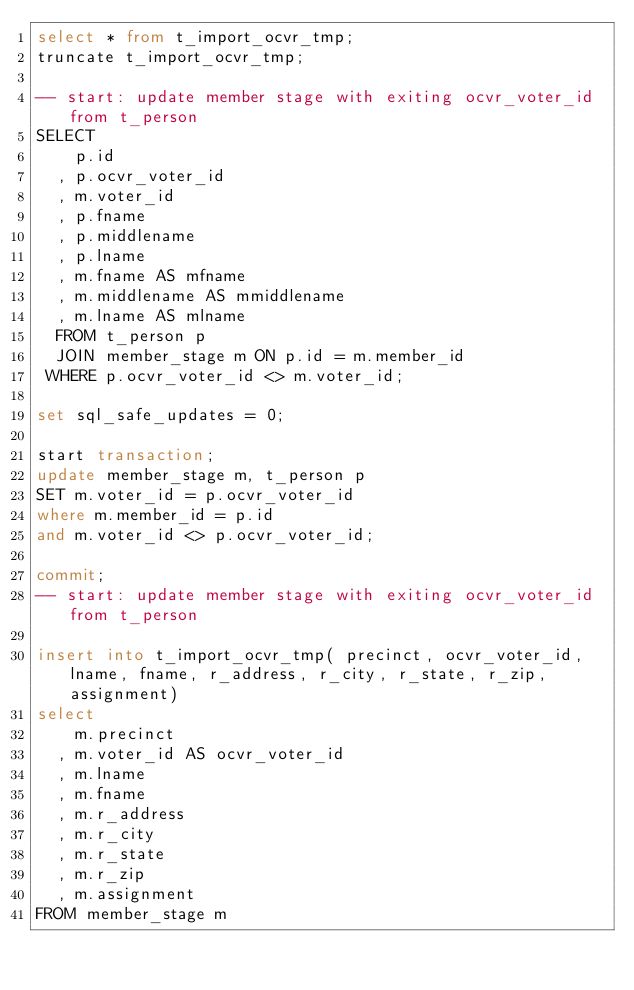Convert code to text. <code><loc_0><loc_0><loc_500><loc_500><_SQL_>select * from t_import_ocvr_tmp;
truncate t_import_ocvr_tmp;

-- start: update member stage with exiting ocvr_voter_id from t_person
SELECT
    p.id
  , p.ocvr_voter_id
  , m.voter_id
  , p.fname
  , p.middlename
  , p.lname
  , m.fname AS mfname
  , m.middlename AS mmiddlename
  , m.lname AS mlname
  FROM t_person p 
  JOIN member_stage m ON p.id = m.member_id
 WHERE p.ocvr_voter_id <> m.voter_id;

set sql_safe_updates = 0;

start transaction;
update member_stage m, t_person p
SET m.voter_id = p.ocvr_voter_id
where m.member_id = p.id
and m.voter_id <> p.ocvr_voter_id;

commit;
-- start: update member stage with exiting ocvr_voter_id from t_person

insert into t_import_ocvr_tmp( precinct, ocvr_voter_id, lname, fname, r_address, r_city, r_state, r_zip, assignment)
select 
    m.precinct
  , m.voter_id AS ocvr_voter_id
  , m.lname
  , m.fname
  , m.r_address
  , m.r_city
  , m.r_state
  , m.r_zip
  , m.assignment
FROM member_stage m </code> 